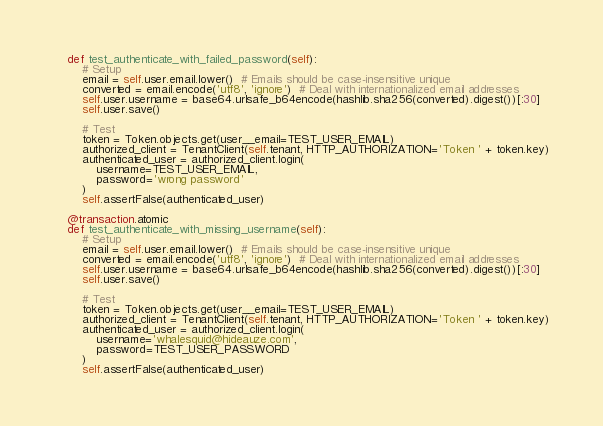<code> <loc_0><loc_0><loc_500><loc_500><_Python_>    def test_authenticate_with_failed_password(self):
        # Setup
        email = self.user.email.lower()  # Emails should be case-insensitive unique
        converted = email.encode('utf8', 'ignore')  # Deal with internationalized email addresses
        self.user.username = base64.urlsafe_b64encode(hashlib.sha256(converted).digest())[:30]
        self.user.save()

        # Test
        token = Token.objects.get(user__email=TEST_USER_EMAIL)
        authorized_client = TenantClient(self.tenant, HTTP_AUTHORIZATION='Token ' + token.key)
        authenticated_user = authorized_client.login(
            username=TEST_USER_EMAIL,
            password='wrong password'
        )
        self.assertFalse(authenticated_user)

    @transaction.atomic
    def test_authenticate_with_missing_username(self):
        # Setup
        email = self.user.email.lower()  # Emails should be case-insensitive unique
        converted = email.encode('utf8', 'ignore')  # Deal with internationalized email addresses
        self.user.username = base64.urlsafe_b64encode(hashlib.sha256(converted).digest())[:30]
        self.user.save()

        # Test
        token = Token.objects.get(user__email=TEST_USER_EMAIL)
        authorized_client = TenantClient(self.tenant, HTTP_AUTHORIZATION='Token ' + token.key)
        authenticated_user = authorized_client.login(
            username='whalesquid@hideauze.com',
            password=TEST_USER_PASSWORD
        )
        self.assertFalse(authenticated_user)
</code> 